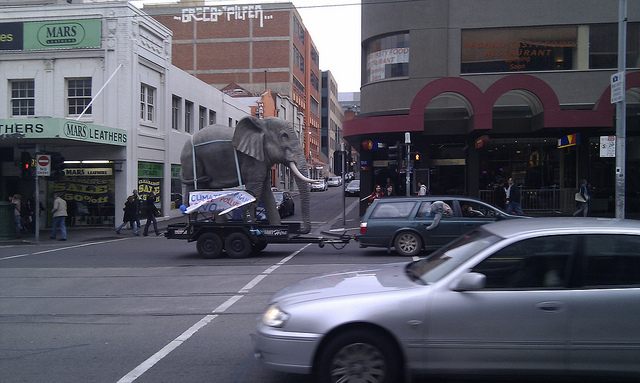<image>What restaurant is closest on the right? I don't know which restaurant is closest on the right. It could be a variety of options such as 'mars leathers', 'mcdonalds', 'diner', 'afghan tasty food', "mariani's", or 'fancy'. What restaurant is closest on the right? I don't know what restaurant is closest on the right. It can be either 'mars leathers', 'mcdonalds', 'diner', 'afghan tasty food', "mariani's" or 'fancy'. 